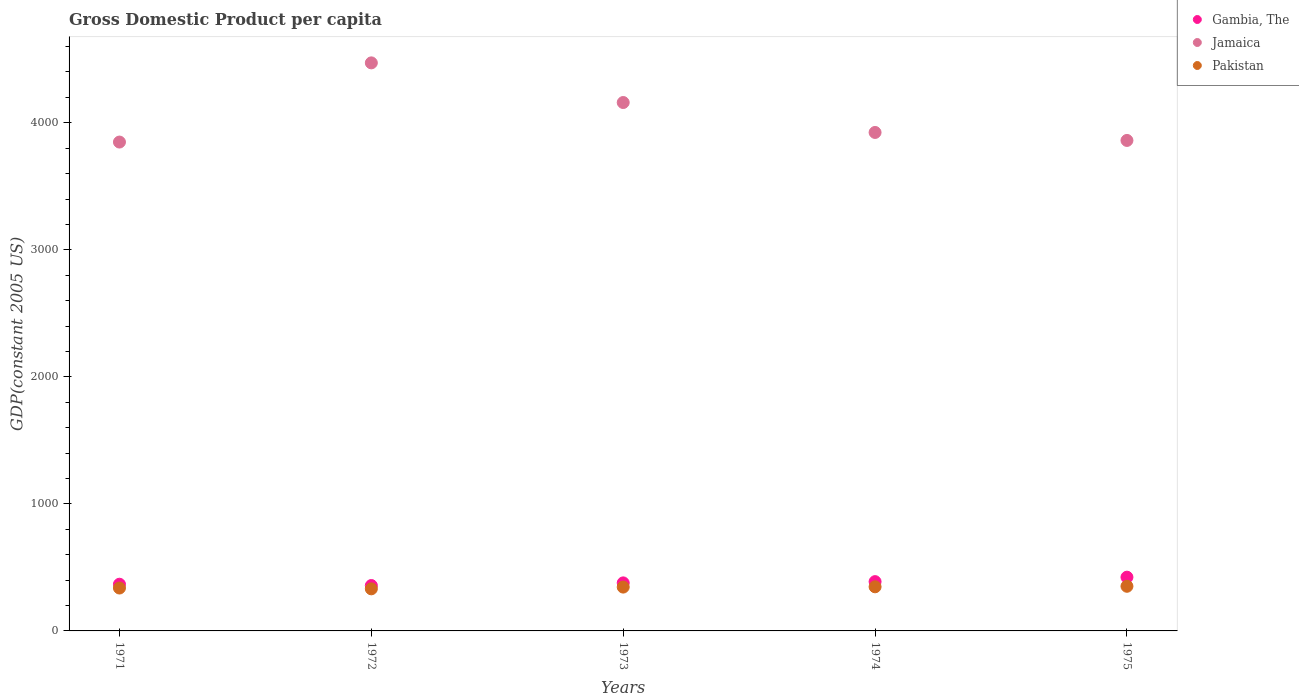How many different coloured dotlines are there?
Provide a succinct answer. 3. What is the GDP per capita in Pakistan in 1975?
Your response must be concise. 351.47. Across all years, what is the maximum GDP per capita in Pakistan?
Provide a succinct answer. 351.47. Across all years, what is the minimum GDP per capita in Jamaica?
Ensure brevity in your answer.  3848.37. In which year was the GDP per capita in Gambia, The maximum?
Ensure brevity in your answer.  1975. In which year was the GDP per capita in Jamaica minimum?
Ensure brevity in your answer.  1971. What is the total GDP per capita in Jamaica in the graph?
Provide a succinct answer. 2.03e+04. What is the difference between the GDP per capita in Pakistan in 1973 and that in 1975?
Your response must be concise. -6.47. What is the difference between the GDP per capita in Gambia, The in 1975 and the GDP per capita in Jamaica in 1974?
Provide a short and direct response. -3500.94. What is the average GDP per capita in Gambia, The per year?
Give a very brief answer. 382.81. In the year 1975, what is the difference between the GDP per capita in Jamaica and GDP per capita in Gambia, The?
Make the answer very short. 3438.11. What is the ratio of the GDP per capita in Pakistan in 1972 to that in 1974?
Ensure brevity in your answer.  0.95. Is the GDP per capita in Jamaica in 1974 less than that in 1975?
Make the answer very short. No. Is the difference between the GDP per capita in Jamaica in 1972 and 1974 greater than the difference between the GDP per capita in Gambia, The in 1972 and 1974?
Offer a terse response. Yes. What is the difference between the highest and the second highest GDP per capita in Pakistan?
Offer a terse response. 4.23. What is the difference between the highest and the lowest GDP per capita in Gambia, The?
Provide a succinct answer. 65.74. Is the sum of the GDP per capita in Jamaica in 1971 and 1974 greater than the maximum GDP per capita in Pakistan across all years?
Give a very brief answer. Yes. Is the GDP per capita in Pakistan strictly greater than the GDP per capita in Jamaica over the years?
Your answer should be very brief. No. Is the GDP per capita in Jamaica strictly less than the GDP per capita in Pakistan over the years?
Offer a terse response. No. How many dotlines are there?
Your answer should be compact. 3. Are the values on the major ticks of Y-axis written in scientific E-notation?
Make the answer very short. No. Does the graph contain any zero values?
Provide a short and direct response. No. Does the graph contain grids?
Make the answer very short. No. Where does the legend appear in the graph?
Your answer should be very brief. Top right. How are the legend labels stacked?
Provide a short and direct response. Vertical. What is the title of the graph?
Offer a terse response. Gross Domestic Product per capita. Does "Least developed countries" appear as one of the legend labels in the graph?
Make the answer very short. No. What is the label or title of the Y-axis?
Offer a very short reply. GDP(constant 2005 US). What is the GDP(constant 2005 US) in Gambia, The in 1971?
Provide a short and direct response. 367.56. What is the GDP(constant 2005 US) in Jamaica in 1971?
Make the answer very short. 3848.37. What is the GDP(constant 2005 US) of Pakistan in 1971?
Your answer should be very brief. 337.69. What is the GDP(constant 2005 US) of Gambia, The in 1972?
Your answer should be very brief. 357.31. What is the GDP(constant 2005 US) of Jamaica in 1972?
Offer a very short reply. 4471.74. What is the GDP(constant 2005 US) in Pakistan in 1972?
Provide a succinct answer. 331.28. What is the GDP(constant 2005 US) in Gambia, The in 1973?
Ensure brevity in your answer.  378.15. What is the GDP(constant 2005 US) of Jamaica in 1973?
Your response must be concise. 4159.63. What is the GDP(constant 2005 US) in Pakistan in 1973?
Offer a very short reply. 345. What is the GDP(constant 2005 US) of Gambia, The in 1974?
Ensure brevity in your answer.  387.98. What is the GDP(constant 2005 US) in Jamaica in 1974?
Your answer should be compact. 3923.99. What is the GDP(constant 2005 US) in Pakistan in 1974?
Provide a short and direct response. 347.24. What is the GDP(constant 2005 US) of Gambia, The in 1975?
Offer a very short reply. 423.05. What is the GDP(constant 2005 US) in Jamaica in 1975?
Your answer should be very brief. 3861.15. What is the GDP(constant 2005 US) in Pakistan in 1975?
Your answer should be very brief. 351.47. Across all years, what is the maximum GDP(constant 2005 US) in Gambia, The?
Give a very brief answer. 423.05. Across all years, what is the maximum GDP(constant 2005 US) of Jamaica?
Provide a short and direct response. 4471.74. Across all years, what is the maximum GDP(constant 2005 US) of Pakistan?
Keep it short and to the point. 351.47. Across all years, what is the minimum GDP(constant 2005 US) of Gambia, The?
Your response must be concise. 357.31. Across all years, what is the minimum GDP(constant 2005 US) in Jamaica?
Offer a terse response. 3848.37. Across all years, what is the minimum GDP(constant 2005 US) of Pakistan?
Give a very brief answer. 331.28. What is the total GDP(constant 2005 US) of Gambia, The in the graph?
Make the answer very short. 1914.05. What is the total GDP(constant 2005 US) of Jamaica in the graph?
Give a very brief answer. 2.03e+04. What is the total GDP(constant 2005 US) in Pakistan in the graph?
Provide a short and direct response. 1712.69. What is the difference between the GDP(constant 2005 US) in Gambia, The in 1971 and that in 1972?
Offer a very short reply. 10.25. What is the difference between the GDP(constant 2005 US) in Jamaica in 1971 and that in 1972?
Give a very brief answer. -623.37. What is the difference between the GDP(constant 2005 US) in Pakistan in 1971 and that in 1972?
Ensure brevity in your answer.  6.41. What is the difference between the GDP(constant 2005 US) in Gambia, The in 1971 and that in 1973?
Offer a terse response. -10.59. What is the difference between the GDP(constant 2005 US) in Jamaica in 1971 and that in 1973?
Keep it short and to the point. -311.27. What is the difference between the GDP(constant 2005 US) in Pakistan in 1971 and that in 1973?
Make the answer very short. -7.31. What is the difference between the GDP(constant 2005 US) in Gambia, The in 1971 and that in 1974?
Provide a short and direct response. -20.43. What is the difference between the GDP(constant 2005 US) of Jamaica in 1971 and that in 1974?
Ensure brevity in your answer.  -75.62. What is the difference between the GDP(constant 2005 US) of Pakistan in 1971 and that in 1974?
Provide a succinct answer. -9.55. What is the difference between the GDP(constant 2005 US) of Gambia, The in 1971 and that in 1975?
Provide a short and direct response. -55.49. What is the difference between the GDP(constant 2005 US) in Jamaica in 1971 and that in 1975?
Your answer should be very brief. -12.79. What is the difference between the GDP(constant 2005 US) in Pakistan in 1971 and that in 1975?
Provide a short and direct response. -13.78. What is the difference between the GDP(constant 2005 US) in Gambia, The in 1972 and that in 1973?
Ensure brevity in your answer.  -20.84. What is the difference between the GDP(constant 2005 US) in Jamaica in 1972 and that in 1973?
Provide a succinct answer. 312.1. What is the difference between the GDP(constant 2005 US) in Pakistan in 1972 and that in 1973?
Your answer should be compact. -13.72. What is the difference between the GDP(constant 2005 US) of Gambia, The in 1972 and that in 1974?
Keep it short and to the point. -30.68. What is the difference between the GDP(constant 2005 US) of Jamaica in 1972 and that in 1974?
Ensure brevity in your answer.  547.75. What is the difference between the GDP(constant 2005 US) of Pakistan in 1972 and that in 1974?
Offer a very short reply. -15.96. What is the difference between the GDP(constant 2005 US) in Gambia, The in 1972 and that in 1975?
Ensure brevity in your answer.  -65.74. What is the difference between the GDP(constant 2005 US) of Jamaica in 1972 and that in 1975?
Your response must be concise. 610.58. What is the difference between the GDP(constant 2005 US) of Pakistan in 1972 and that in 1975?
Make the answer very short. -20.2. What is the difference between the GDP(constant 2005 US) of Gambia, The in 1973 and that in 1974?
Your answer should be very brief. -9.83. What is the difference between the GDP(constant 2005 US) in Jamaica in 1973 and that in 1974?
Provide a succinct answer. 235.65. What is the difference between the GDP(constant 2005 US) in Pakistan in 1973 and that in 1974?
Give a very brief answer. -2.24. What is the difference between the GDP(constant 2005 US) in Gambia, The in 1973 and that in 1975?
Make the answer very short. -44.9. What is the difference between the GDP(constant 2005 US) of Jamaica in 1973 and that in 1975?
Your answer should be compact. 298.48. What is the difference between the GDP(constant 2005 US) of Pakistan in 1973 and that in 1975?
Give a very brief answer. -6.47. What is the difference between the GDP(constant 2005 US) of Gambia, The in 1974 and that in 1975?
Offer a very short reply. -35.06. What is the difference between the GDP(constant 2005 US) of Jamaica in 1974 and that in 1975?
Offer a terse response. 62.83. What is the difference between the GDP(constant 2005 US) of Pakistan in 1974 and that in 1975?
Your answer should be compact. -4.23. What is the difference between the GDP(constant 2005 US) of Gambia, The in 1971 and the GDP(constant 2005 US) of Jamaica in 1972?
Give a very brief answer. -4104.18. What is the difference between the GDP(constant 2005 US) in Gambia, The in 1971 and the GDP(constant 2005 US) in Pakistan in 1972?
Give a very brief answer. 36.28. What is the difference between the GDP(constant 2005 US) of Jamaica in 1971 and the GDP(constant 2005 US) of Pakistan in 1972?
Your answer should be compact. 3517.09. What is the difference between the GDP(constant 2005 US) in Gambia, The in 1971 and the GDP(constant 2005 US) in Jamaica in 1973?
Provide a short and direct response. -3792.08. What is the difference between the GDP(constant 2005 US) in Gambia, The in 1971 and the GDP(constant 2005 US) in Pakistan in 1973?
Your answer should be compact. 22.56. What is the difference between the GDP(constant 2005 US) in Jamaica in 1971 and the GDP(constant 2005 US) in Pakistan in 1973?
Your response must be concise. 3503.37. What is the difference between the GDP(constant 2005 US) of Gambia, The in 1971 and the GDP(constant 2005 US) of Jamaica in 1974?
Ensure brevity in your answer.  -3556.43. What is the difference between the GDP(constant 2005 US) of Gambia, The in 1971 and the GDP(constant 2005 US) of Pakistan in 1974?
Your response must be concise. 20.32. What is the difference between the GDP(constant 2005 US) in Jamaica in 1971 and the GDP(constant 2005 US) in Pakistan in 1974?
Your response must be concise. 3501.13. What is the difference between the GDP(constant 2005 US) of Gambia, The in 1971 and the GDP(constant 2005 US) of Jamaica in 1975?
Offer a very short reply. -3493.6. What is the difference between the GDP(constant 2005 US) in Gambia, The in 1971 and the GDP(constant 2005 US) in Pakistan in 1975?
Ensure brevity in your answer.  16.08. What is the difference between the GDP(constant 2005 US) in Jamaica in 1971 and the GDP(constant 2005 US) in Pakistan in 1975?
Provide a short and direct response. 3496.89. What is the difference between the GDP(constant 2005 US) in Gambia, The in 1972 and the GDP(constant 2005 US) in Jamaica in 1973?
Keep it short and to the point. -3802.33. What is the difference between the GDP(constant 2005 US) in Gambia, The in 1972 and the GDP(constant 2005 US) in Pakistan in 1973?
Your response must be concise. 12.31. What is the difference between the GDP(constant 2005 US) in Jamaica in 1972 and the GDP(constant 2005 US) in Pakistan in 1973?
Your answer should be very brief. 4126.73. What is the difference between the GDP(constant 2005 US) in Gambia, The in 1972 and the GDP(constant 2005 US) in Jamaica in 1974?
Your answer should be very brief. -3566.68. What is the difference between the GDP(constant 2005 US) in Gambia, The in 1972 and the GDP(constant 2005 US) in Pakistan in 1974?
Provide a succinct answer. 10.07. What is the difference between the GDP(constant 2005 US) of Jamaica in 1972 and the GDP(constant 2005 US) of Pakistan in 1974?
Keep it short and to the point. 4124.5. What is the difference between the GDP(constant 2005 US) in Gambia, The in 1972 and the GDP(constant 2005 US) in Jamaica in 1975?
Offer a very short reply. -3503.85. What is the difference between the GDP(constant 2005 US) of Gambia, The in 1972 and the GDP(constant 2005 US) of Pakistan in 1975?
Provide a short and direct response. 5.83. What is the difference between the GDP(constant 2005 US) of Jamaica in 1972 and the GDP(constant 2005 US) of Pakistan in 1975?
Your answer should be compact. 4120.26. What is the difference between the GDP(constant 2005 US) in Gambia, The in 1973 and the GDP(constant 2005 US) in Jamaica in 1974?
Provide a succinct answer. -3545.84. What is the difference between the GDP(constant 2005 US) of Gambia, The in 1973 and the GDP(constant 2005 US) of Pakistan in 1974?
Offer a very short reply. 30.91. What is the difference between the GDP(constant 2005 US) in Jamaica in 1973 and the GDP(constant 2005 US) in Pakistan in 1974?
Offer a terse response. 3812.39. What is the difference between the GDP(constant 2005 US) in Gambia, The in 1973 and the GDP(constant 2005 US) in Jamaica in 1975?
Your response must be concise. -3483.01. What is the difference between the GDP(constant 2005 US) in Gambia, The in 1973 and the GDP(constant 2005 US) in Pakistan in 1975?
Provide a short and direct response. 26.68. What is the difference between the GDP(constant 2005 US) of Jamaica in 1973 and the GDP(constant 2005 US) of Pakistan in 1975?
Give a very brief answer. 3808.16. What is the difference between the GDP(constant 2005 US) in Gambia, The in 1974 and the GDP(constant 2005 US) in Jamaica in 1975?
Give a very brief answer. -3473.17. What is the difference between the GDP(constant 2005 US) of Gambia, The in 1974 and the GDP(constant 2005 US) of Pakistan in 1975?
Give a very brief answer. 36.51. What is the difference between the GDP(constant 2005 US) of Jamaica in 1974 and the GDP(constant 2005 US) of Pakistan in 1975?
Offer a terse response. 3572.52. What is the average GDP(constant 2005 US) in Gambia, The per year?
Offer a terse response. 382.81. What is the average GDP(constant 2005 US) of Jamaica per year?
Give a very brief answer. 4052.98. What is the average GDP(constant 2005 US) of Pakistan per year?
Your answer should be compact. 342.54. In the year 1971, what is the difference between the GDP(constant 2005 US) in Gambia, The and GDP(constant 2005 US) in Jamaica?
Keep it short and to the point. -3480.81. In the year 1971, what is the difference between the GDP(constant 2005 US) of Gambia, The and GDP(constant 2005 US) of Pakistan?
Make the answer very short. 29.86. In the year 1971, what is the difference between the GDP(constant 2005 US) of Jamaica and GDP(constant 2005 US) of Pakistan?
Keep it short and to the point. 3510.67. In the year 1972, what is the difference between the GDP(constant 2005 US) of Gambia, The and GDP(constant 2005 US) of Jamaica?
Make the answer very short. -4114.43. In the year 1972, what is the difference between the GDP(constant 2005 US) in Gambia, The and GDP(constant 2005 US) in Pakistan?
Provide a succinct answer. 26.03. In the year 1972, what is the difference between the GDP(constant 2005 US) in Jamaica and GDP(constant 2005 US) in Pakistan?
Your response must be concise. 4140.46. In the year 1973, what is the difference between the GDP(constant 2005 US) of Gambia, The and GDP(constant 2005 US) of Jamaica?
Provide a short and direct response. -3781.48. In the year 1973, what is the difference between the GDP(constant 2005 US) in Gambia, The and GDP(constant 2005 US) in Pakistan?
Ensure brevity in your answer.  33.15. In the year 1973, what is the difference between the GDP(constant 2005 US) in Jamaica and GDP(constant 2005 US) in Pakistan?
Provide a succinct answer. 3814.63. In the year 1974, what is the difference between the GDP(constant 2005 US) of Gambia, The and GDP(constant 2005 US) of Jamaica?
Provide a short and direct response. -3536.01. In the year 1974, what is the difference between the GDP(constant 2005 US) of Gambia, The and GDP(constant 2005 US) of Pakistan?
Your response must be concise. 40.74. In the year 1974, what is the difference between the GDP(constant 2005 US) of Jamaica and GDP(constant 2005 US) of Pakistan?
Ensure brevity in your answer.  3576.75. In the year 1975, what is the difference between the GDP(constant 2005 US) in Gambia, The and GDP(constant 2005 US) in Jamaica?
Make the answer very short. -3438.11. In the year 1975, what is the difference between the GDP(constant 2005 US) in Gambia, The and GDP(constant 2005 US) in Pakistan?
Make the answer very short. 71.57. In the year 1975, what is the difference between the GDP(constant 2005 US) of Jamaica and GDP(constant 2005 US) of Pakistan?
Your response must be concise. 3509.68. What is the ratio of the GDP(constant 2005 US) in Gambia, The in 1971 to that in 1972?
Provide a succinct answer. 1.03. What is the ratio of the GDP(constant 2005 US) of Jamaica in 1971 to that in 1972?
Your response must be concise. 0.86. What is the ratio of the GDP(constant 2005 US) in Pakistan in 1971 to that in 1972?
Give a very brief answer. 1.02. What is the ratio of the GDP(constant 2005 US) of Jamaica in 1971 to that in 1973?
Your answer should be very brief. 0.93. What is the ratio of the GDP(constant 2005 US) in Pakistan in 1971 to that in 1973?
Ensure brevity in your answer.  0.98. What is the ratio of the GDP(constant 2005 US) of Jamaica in 1971 to that in 1974?
Ensure brevity in your answer.  0.98. What is the ratio of the GDP(constant 2005 US) in Pakistan in 1971 to that in 1974?
Your answer should be compact. 0.97. What is the ratio of the GDP(constant 2005 US) of Gambia, The in 1971 to that in 1975?
Offer a terse response. 0.87. What is the ratio of the GDP(constant 2005 US) of Pakistan in 1971 to that in 1975?
Make the answer very short. 0.96. What is the ratio of the GDP(constant 2005 US) in Gambia, The in 1972 to that in 1973?
Give a very brief answer. 0.94. What is the ratio of the GDP(constant 2005 US) in Jamaica in 1972 to that in 1973?
Make the answer very short. 1.07. What is the ratio of the GDP(constant 2005 US) of Pakistan in 1972 to that in 1973?
Offer a terse response. 0.96. What is the ratio of the GDP(constant 2005 US) in Gambia, The in 1972 to that in 1974?
Offer a very short reply. 0.92. What is the ratio of the GDP(constant 2005 US) in Jamaica in 1972 to that in 1974?
Provide a short and direct response. 1.14. What is the ratio of the GDP(constant 2005 US) in Pakistan in 1972 to that in 1974?
Provide a short and direct response. 0.95. What is the ratio of the GDP(constant 2005 US) in Gambia, The in 1972 to that in 1975?
Give a very brief answer. 0.84. What is the ratio of the GDP(constant 2005 US) in Jamaica in 1972 to that in 1975?
Provide a short and direct response. 1.16. What is the ratio of the GDP(constant 2005 US) of Pakistan in 1972 to that in 1975?
Your answer should be very brief. 0.94. What is the ratio of the GDP(constant 2005 US) of Gambia, The in 1973 to that in 1974?
Provide a succinct answer. 0.97. What is the ratio of the GDP(constant 2005 US) in Jamaica in 1973 to that in 1974?
Make the answer very short. 1.06. What is the ratio of the GDP(constant 2005 US) of Pakistan in 1973 to that in 1974?
Offer a very short reply. 0.99. What is the ratio of the GDP(constant 2005 US) in Gambia, The in 1973 to that in 1975?
Make the answer very short. 0.89. What is the ratio of the GDP(constant 2005 US) in Jamaica in 1973 to that in 1975?
Your answer should be compact. 1.08. What is the ratio of the GDP(constant 2005 US) in Pakistan in 1973 to that in 1975?
Offer a very short reply. 0.98. What is the ratio of the GDP(constant 2005 US) of Gambia, The in 1974 to that in 1975?
Keep it short and to the point. 0.92. What is the ratio of the GDP(constant 2005 US) in Jamaica in 1974 to that in 1975?
Ensure brevity in your answer.  1.02. What is the difference between the highest and the second highest GDP(constant 2005 US) in Gambia, The?
Ensure brevity in your answer.  35.06. What is the difference between the highest and the second highest GDP(constant 2005 US) in Jamaica?
Give a very brief answer. 312.1. What is the difference between the highest and the second highest GDP(constant 2005 US) of Pakistan?
Keep it short and to the point. 4.23. What is the difference between the highest and the lowest GDP(constant 2005 US) of Gambia, The?
Your response must be concise. 65.74. What is the difference between the highest and the lowest GDP(constant 2005 US) of Jamaica?
Make the answer very short. 623.37. What is the difference between the highest and the lowest GDP(constant 2005 US) of Pakistan?
Ensure brevity in your answer.  20.2. 